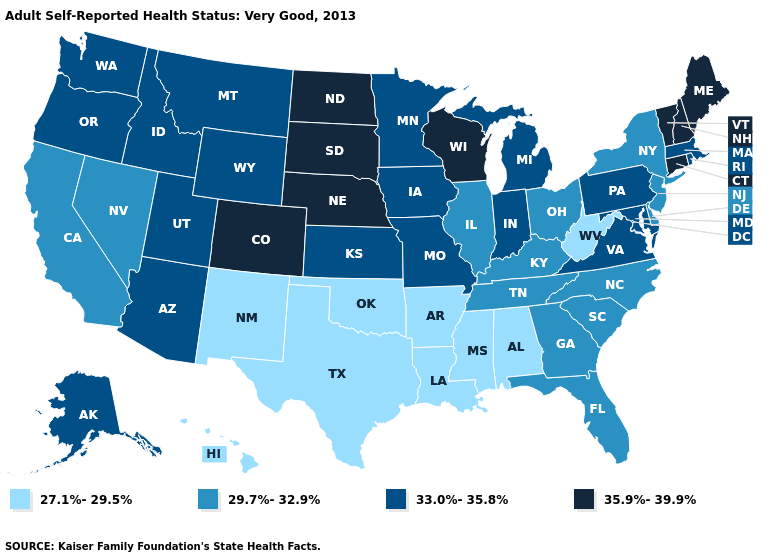Name the states that have a value in the range 33.0%-35.8%?
Give a very brief answer. Alaska, Arizona, Idaho, Indiana, Iowa, Kansas, Maryland, Massachusetts, Michigan, Minnesota, Missouri, Montana, Oregon, Pennsylvania, Rhode Island, Utah, Virginia, Washington, Wyoming. What is the lowest value in the MidWest?
Quick response, please. 29.7%-32.9%. Does Arizona have a lower value than Wisconsin?
Concise answer only. Yes. Name the states that have a value in the range 33.0%-35.8%?
Answer briefly. Alaska, Arizona, Idaho, Indiana, Iowa, Kansas, Maryland, Massachusetts, Michigan, Minnesota, Missouri, Montana, Oregon, Pennsylvania, Rhode Island, Utah, Virginia, Washington, Wyoming. Name the states that have a value in the range 27.1%-29.5%?
Answer briefly. Alabama, Arkansas, Hawaii, Louisiana, Mississippi, New Mexico, Oklahoma, Texas, West Virginia. Does the map have missing data?
Give a very brief answer. No. Name the states that have a value in the range 35.9%-39.9%?
Write a very short answer. Colorado, Connecticut, Maine, Nebraska, New Hampshire, North Dakota, South Dakota, Vermont, Wisconsin. What is the lowest value in the West?
Quick response, please. 27.1%-29.5%. Among the states that border Maine , which have the lowest value?
Quick response, please. New Hampshire. Among the states that border Wyoming , which have the highest value?
Keep it brief. Colorado, Nebraska, South Dakota. Does Texas have a higher value than New York?
Short answer required. No. Does the first symbol in the legend represent the smallest category?
Be succinct. Yes. Name the states that have a value in the range 33.0%-35.8%?
Give a very brief answer. Alaska, Arizona, Idaho, Indiana, Iowa, Kansas, Maryland, Massachusetts, Michigan, Minnesota, Missouri, Montana, Oregon, Pennsylvania, Rhode Island, Utah, Virginia, Washington, Wyoming. Does Texas have a higher value than Virginia?
Answer briefly. No. What is the value of California?
Short answer required. 29.7%-32.9%. 